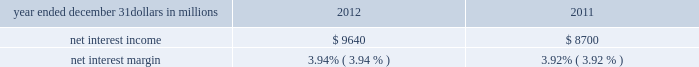Consolidated income statement review our consolidated income statement is presented in item 8 of this report .
Net income for 2012 was $ 3.0 billion compared with $ 3.1 billion for 2011 .
Revenue growth of 8 percent and a decline in the provision for credit losses were more than offset by a 16 percent increase in noninterest expense in 2012 compared to 2011 .
Further detail is included in the net interest income , noninterest income , provision for credit losses and noninterest expense portions of this consolidated income statement review .
Net interest income table 2 : net interest income and net interest margin year ended december 31 dollars in millions 2012 2011 .
Changes in net interest income and margin result from the interaction of the volume and composition of interest-earning assets and related yields , interest-bearing liabilities and related rates paid , and noninterest-bearing sources of funding .
See the statistical information ( unaudited ) 2013 average consolidated balance sheet and net interest analysis and analysis of year-to-year changes in net interest income in item 8 of this report and the discussion of purchase accounting accretion of purchased impaired loans in the consolidated balance sheet review in this item 7 for additional information .
The increase in net interest income in 2012 compared with 2011 was primarily due to the impact of the rbc bank ( usa ) acquisition , organic loan growth and lower funding costs .
Purchase accounting accretion remained stable at $ 1.1 billion in both periods .
The net interest margin was 3.94% ( 3.94 % ) for 2012 and 3.92% ( 3.92 % ) for 2011 .
The increase in the comparison was primarily due to a decrease in the weighted-average rate accrued on total interest- bearing liabilities of 29 basis points , largely offset by a 21 basis point decrease on the yield on total interest-earning assets .
The decrease in the rate on interest-bearing liabilities was primarily due to the runoff of maturing retail certificates of deposit and the redemption of additional trust preferred and hybrid capital securities during 2012 , in addition to an increase in fhlb borrowings and commercial paper as lower-cost funding sources .
The decrease in the yield on interest-earning assets was primarily due to lower rates on new loan volume and lower yields on new securities in the current low rate environment .
With respect to the first quarter of 2013 , we expect net interest income to decline by two to three percent compared to fourth quarter 2012 net interest income of $ 2.4 billion , due to a decrease in purchase accounting accretion of up to $ 50 to $ 60 million , including lower expected cash recoveries .
For the full year 2013 , we expect net interest income to decrease compared with 2012 , assuming an expected decline in purchase accounting accretion of approximately $ 400 million , while core net interest income is expected to increase in the year-over-year comparison .
We believe our net interest margin will come under pressure in 2013 , due to the expected decline in purchase accounting accretion and assuming that the current low rate environment continues .
Noninterest income noninterest income totaled $ 5.9 billion for 2012 and $ 5.6 billion for 2011 .
The overall increase in the comparison was primarily due to an increase in residential mortgage loan sales revenue driven by higher loan origination volume , gains on sales of visa class b common shares and higher corporate service fees , largely offset by higher provision for residential mortgage repurchase obligations .
Asset management revenue , including blackrock , totaled $ 1.2 billion in 2012 compared with $ 1.1 billion in 2011 .
This increase was primarily due to higher earnings from our blackrock investment .
Discretionary assets under management increased to $ 112 billion at december 31 , 2012 compared with $ 107 billion at december 31 , 2011 driven by stronger average equity markets , positive net flows and strong sales performance .
For 2012 , consumer services fees were $ 1.1 billion compared with $ 1.2 billion in 2011 .
The decline reflected the regulatory impact of lower interchange fees on debit card transactions partially offset by customer growth .
As further discussed in the retail banking portion of the business segments review section of this item 7 , the dodd-frank limits on interchange rates were effective october 1 , 2011 and had a negative impact on revenue of approximately $ 314 million in 2012 and $ 75 million in 2011 .
This impact was partially offset by higher volumes of merchant , customer credit card and debit card transactions and the impact of the rbc bank ( usa ) acquisition .
Corporate services revenue increased by $ .3 billion , or 30 percent , to $ 1.2 billion in 2012 compared with $ .9 billion in 2011 due to higher commercial mortgage servicing revenue and higher merger and acquisition advisory fees in 2012 .
The major components of corporate services revenue are treasury management revenue , corporate finance fees , including revenue from capital markets-related products and services , and commercial mortgage servicing revenue , including commercial mortgage banking activities .
See the product revenue portion of this consolidated income statement review for further detail .
The pnc financial services group , inc .
2013 form 10-k 39 .
What was the percentage change in the non interest income from from 2011 to 2012? 
Computations: ((5.9 - 5.6) / 5.6)
Answer: 0.05357. 